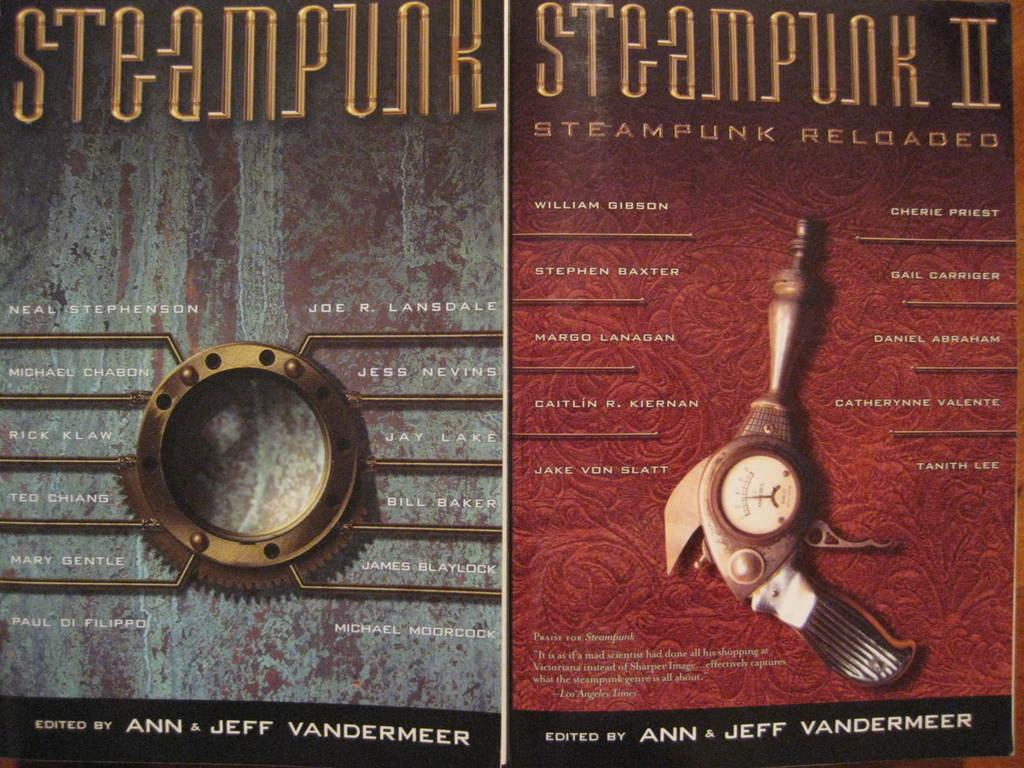<image>
Provide a brief description of the given image. The books shown here are both Steampunk and Steampunk II 